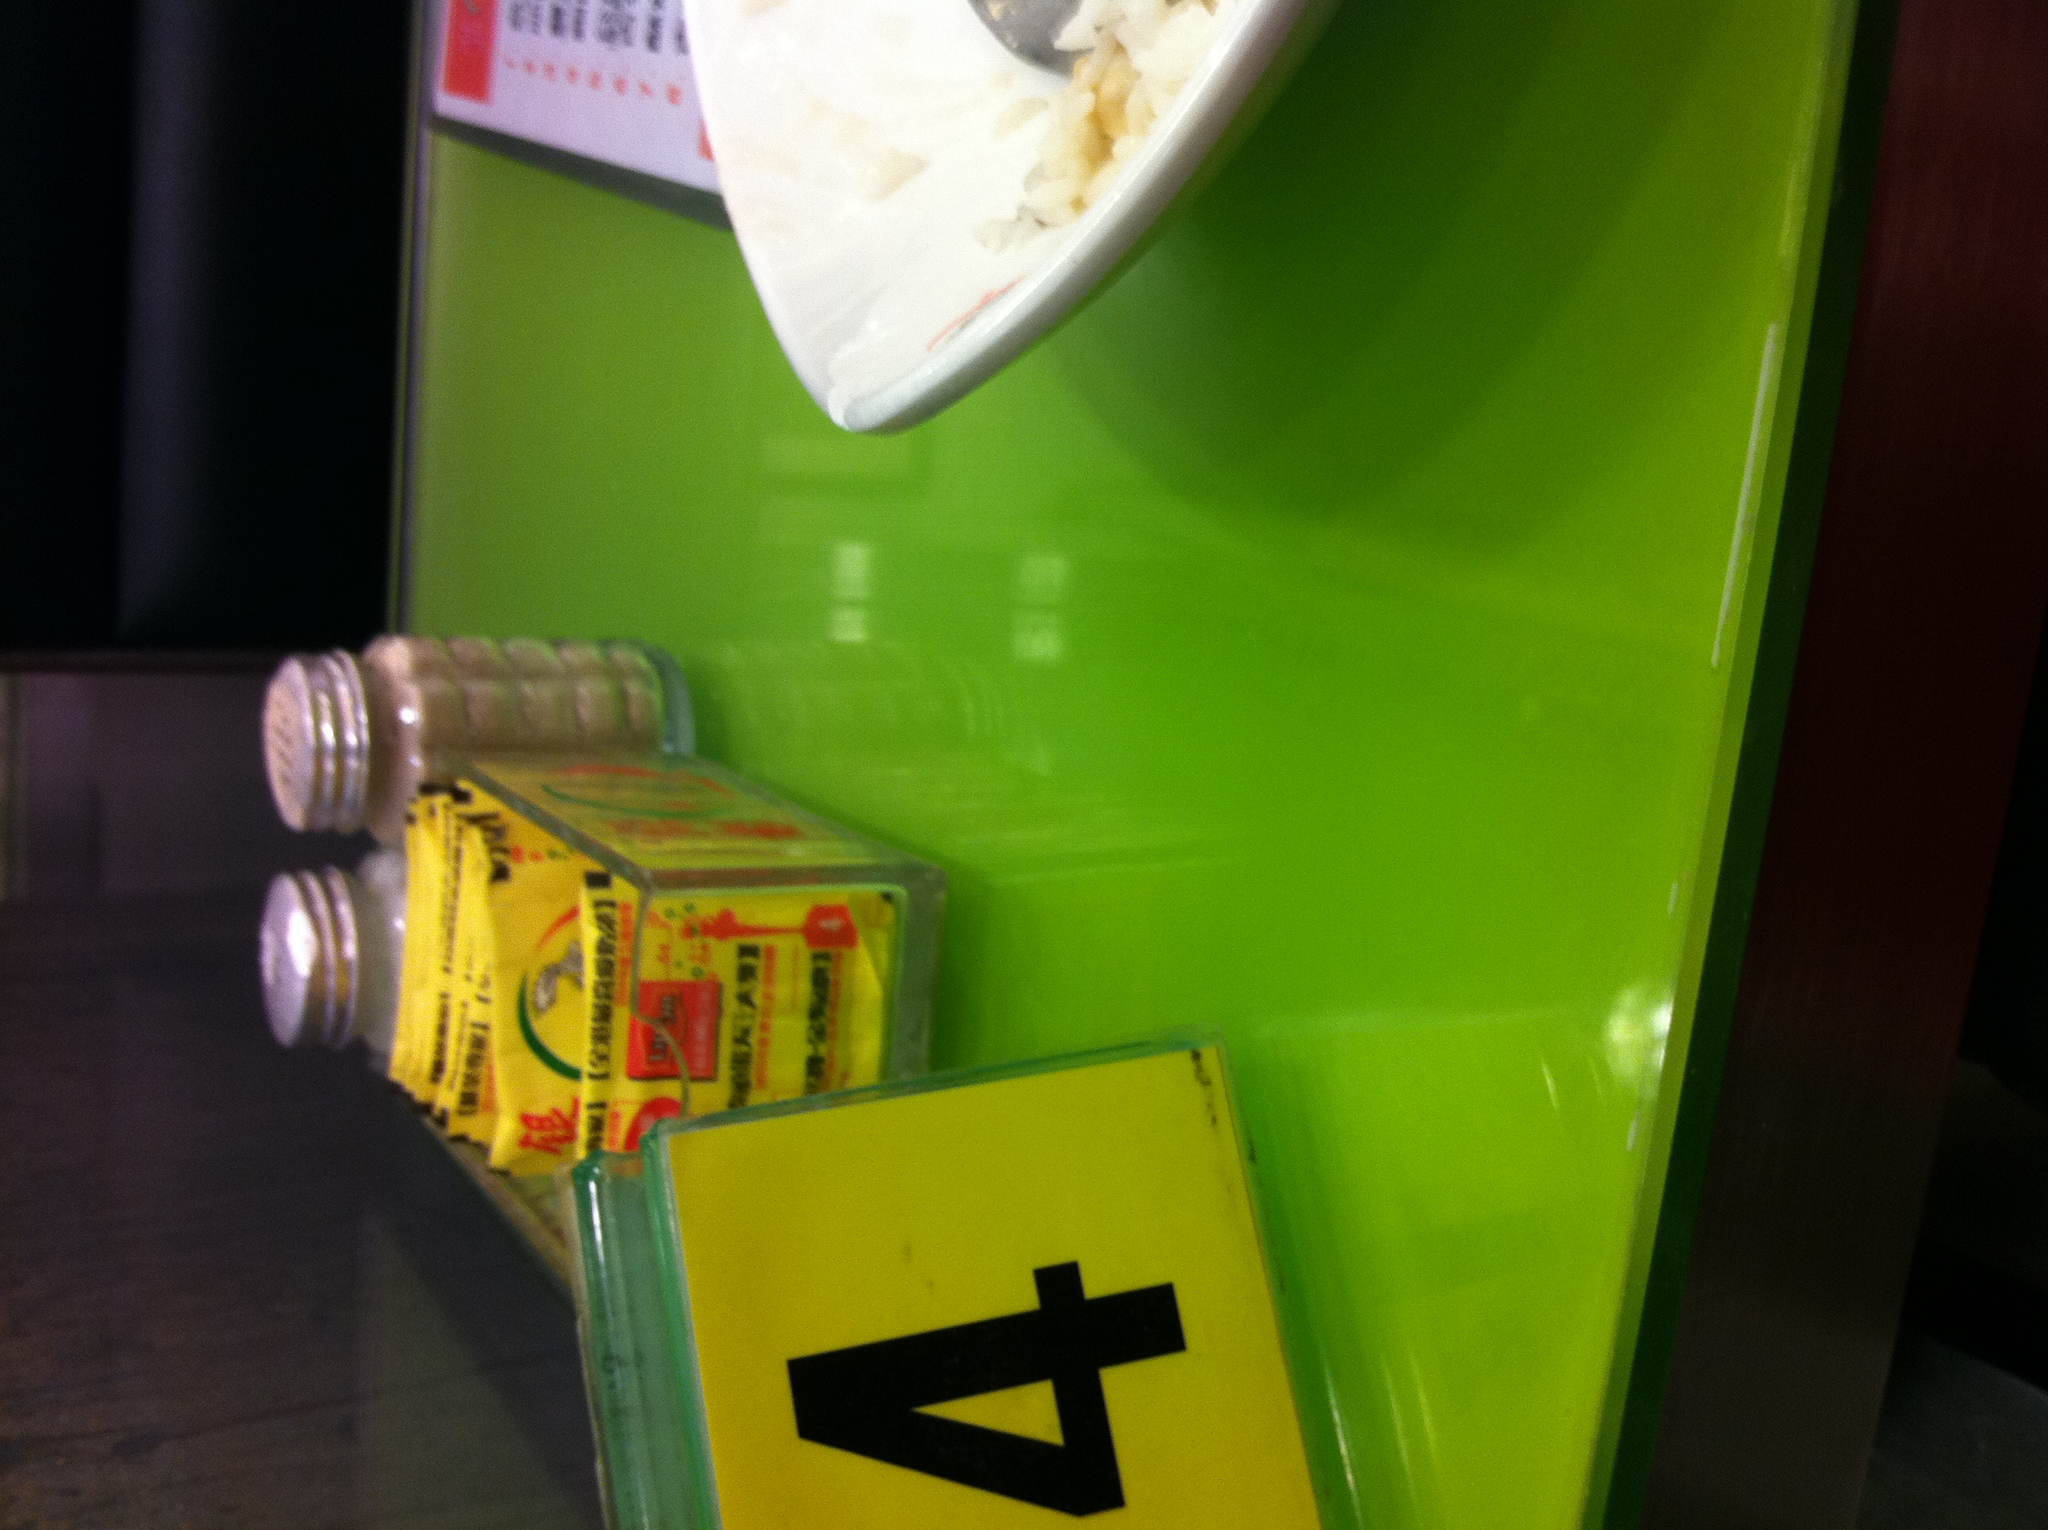If this table could talk, what story would it tell about the people who have sat here? If this table could talk, it might share stories of countless diners who have enjoyed their meals here. From students grabbing a quick bite between classes, to friends catching up over a bowl of rice. It might recount the laughter, the serious conversations and decisions made, and the variety of delicious dishes that have been laid upon its bright green surface. Each scratch, stain, and mark on the table could tell a part of the history, adding character to this simple piece of furniture. 